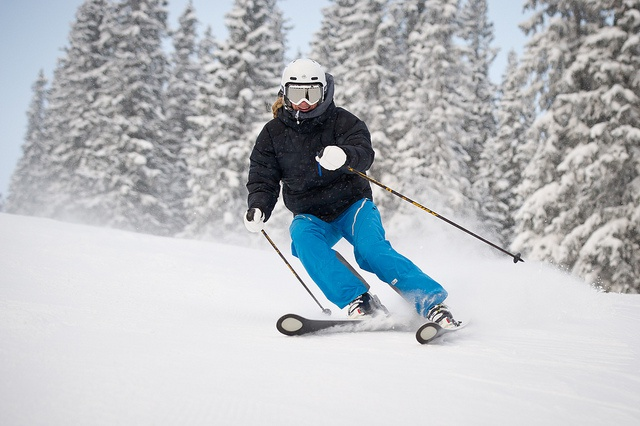Describe the objects in this image and their specific colors. I can see people in darkgray, black, teal, and lightgray tones and skis in darkgray, lightgray, gray, and black tones in this image. 